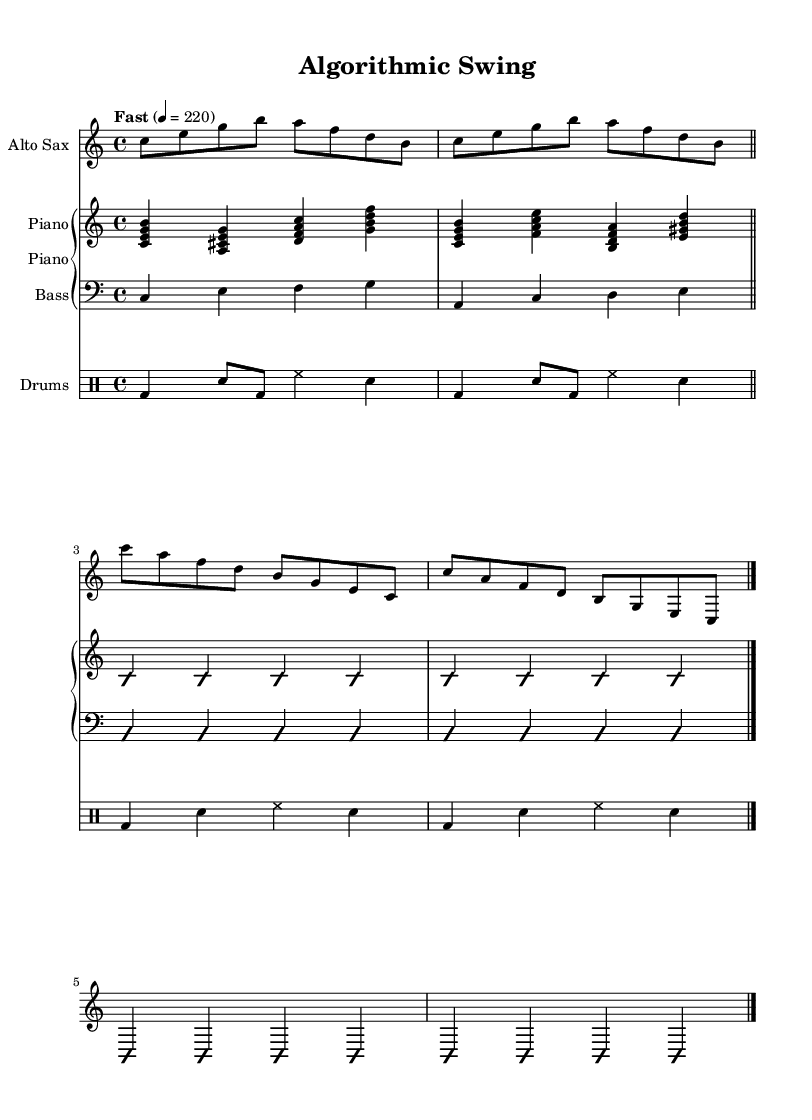What is the key signature of this music? The key signature is indicated by the absence of sharps or flats at the beginning of the staff, which corresponds to C major.
Answer: C major What is the time signature of this music? The time signature is shown as a '4/4' notated at the beginning of the first staff, meaning there are four beats in each measure.
Answer: 4/4 What is the tempo marking of this piece? The tempo marking is indicated by the text "Fast" with the metronome marking of 220, which guides the speed you should play.
Answer: Fast 4 = 220 What type of improvisation is indicated for the musicians? The indications 'improvisationOn' and 'improvisationOff' suggest that the musicians are prompted to improvise during certain sections of the piece.
Answer: Improvisation Which instruments are featured in this composition? The score clearly shows three instrumental parts: Alto Sax, Piano, and Drums, as indicated by the instrument names above each staff.
Answer: Alto Sax, Piano, Drums What kind of rhythm pattern does the drums part use in the first section? The drums part has a combination of bass drum (bd), snare (sn), and hi-hat (hh) with alternating patterns across the measures, creating a swing rhythm typical in jazz.
Answer: Swing rhythm 